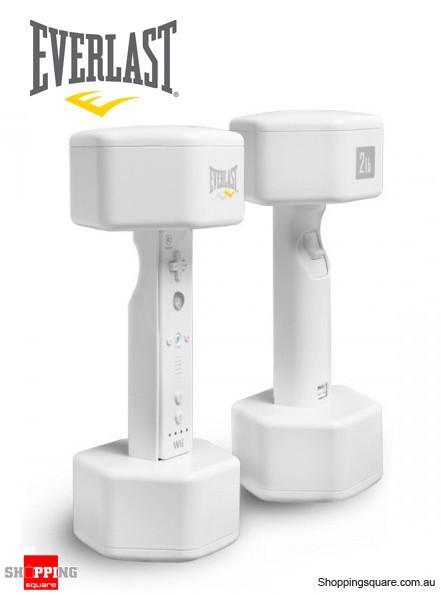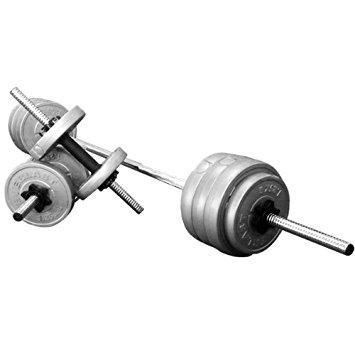The first image is the image on the left, the second image is the image on the right. Examine the images to the left and right. Is the description "The left image contains two dumbells without pipe sticking out." accurate? Answer yes or no. Yes. The first image is the image on the left, the second image is the image on the right. Assess this claim about the two images: "There are exactly three dumbbells.". Correct or not? Answer yes or no. No. 